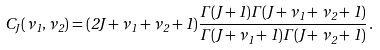Convert formula to latex. <formula><loc_0><loc_0><loc_500><loc_500>C _ { J } ( \nu _ { 1 } , \nu _ { 2 } ) = ( 2 J + \nu _ { 1 } + \nu _ { 2 } + 1 ) \frac { { \mathit \Gamma } ( J + 1 ) { \mathit \Gamma } ( J + \nu _ { 1 } + \nu _ { 2 } + 1 ) } { { \mathit \Gamma } ( J + \nu _ { 1 } + 1 ) { \mathit \Gamma } ( J + \nu _ { 2 } + 1 ) } \, .</formula> 